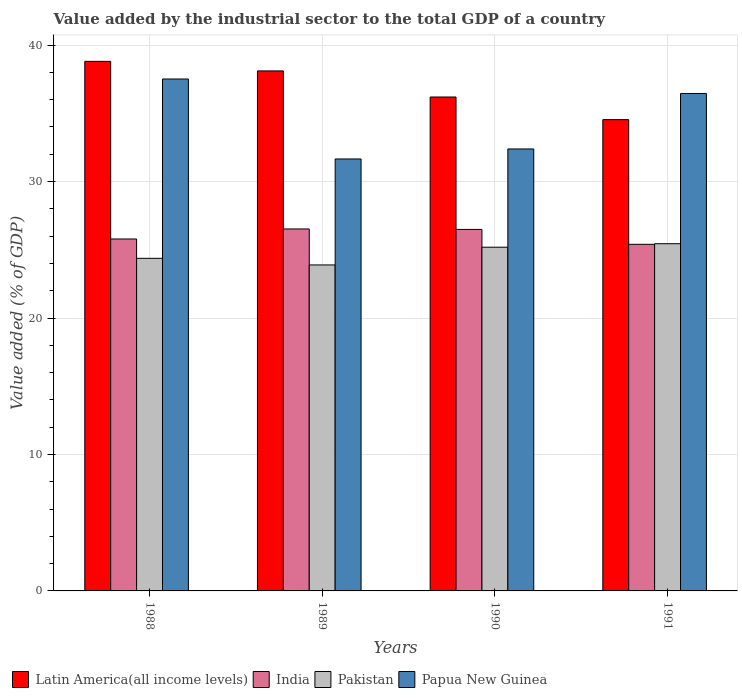How many different coloured bars are there?
Your response must be concise. 4. Are the number of bars per tick equal to the number of legend labels?
Your answer should be very brief. Yes. Are the number of bars on each tick of the X-axis equal?
Provide a short and direct response. Yes. How many bars are there on the 4th tick from the left?
Keep it short and to the point. 4. How many bars are there on the 3rd tick from the right?
Make the answer very short. 4. In how many cases, is the number of bars for a given year not equal to the number of legend labels?
Offer a very short reply. 0. What is the value added by the industrial sector to the total GDP in Papua New Guinea in 1991?
Ensure brevity in your answer.  36.46. Across all years, what is the maximum value added by the industrial sector to the total GDP in Pakistan?
Provide a succinct answer. 25.45. Across all years, what is the minimum value added by the industrial sector to the total GDP in Pakistan?
Provide a short and direct response. 23.89. What is the total value added by the industrial sector to the total GDP in Latin America(all income levels) in the graph?
Your answer should be compact. 147.66. What is the difference between the value added by the industrial sector to the total GDP in Pakistan in 1988 and that in 1991?
Offer a very short reply. -1.07. What is the difference between the value added by the industrial sector to the total GDP in Papua New Guinea in 1989 and the value added by the industrial sector to the total GDP in Latin America(all income levels) in 1991?
Your answer should be compact. -2.88. What is the average value added by the industrial sector to the total GDP in Papua New Guinea per year?
Ensure brevity in your answer.  34.51. In the year 1990, what is the difference between the value added by the industrial sector to the total GDP in Latin America(all income levels) and value added by the industrial sector to the total GDP in Pakistan?
Make the answer very short. 11.01. In how many years, is the value added by the industrial sector to the total GDP in Latin America(all income levels) greater than 16 %?
Offer a terse response. 4. What is the ratio of the value added by the industrial sector to the total GDP in Latin America(all income levels) in 1989 to that in 1991?
Provide a succinct answer. 1.1. Is the value added by the industrial sector to the total GDP in Pakistan in 1989 less than that in 1990?
Your answer should be very brief. Yes. What is the difference between the highest and the second highest value added by the industrial sector to the total GDP in Papua New Guinea?
Your answer should be compact. 1.06. What is the difference between the highest and the lowest value added by the industrial sector to the total GDP in Papua New Guinea?
Provide a short and direct response. 5.86. In how many years, is the value added by the industrial sector to the total GDP in Pakistan greater than the average value added by the industrial sector to the total GDP in Pakistan taken over all years?
Keep it short and to the point. 2. Is the sum of the value added by the industrial sector to the total GDP in Papua New Guinea in 1989 and 1990 greater than the maximum value added by the industrial sector to the total GDP in Pakistan across all years?
Provide a short and direct response. Yes. What does the 3rd bar from the left in 1990 represents?
Ensure brevity in your answer.  Pakistan. What does the 4th bar from the right in 1991 represents?
Make the answer very short. Latin America(all income levels). Is it the case that in every year, the sum of the value added by the industrial sector to the total GDP in India and value added by the industrial sector to the total GDP in Papua New Guinea is greater than the value added by the industrial sector to the total GDP in Latin America(all income levels)?
Make the answer very short. Yes. How many bars are there?
Provide a short and direct response. 16. What is the difference between two consecutive major ticks on the Y-axis?
Your answer should be compact. 10. Are the values on the major ticks of Y-axis written in scientific E-notation?
Offer a terse response. No. What is the title of the graph?
Keep it short and to the point. Value added by the industrial sector to the total GDP of a country. What is the label or title of the Y-axis?
Give a very brief answer. Value added (% of GDP). What is the Value added (% of GDP) in Latin America(all income levels) in 1988?
Give a very brief answer. 38.81. What is the Value added (% of GDP) in India in 1988?
Provide a succinct answer. 25.79. What is the Value added (% of GDP) of Pakistan in 1988?
Ensure brevity in your answer.  24.38. What is the Value added (% of GDP) in Papua New Guinea in 1988?
Your answer should be compact. 37.52. What is the Value added (% of GDP) in Latin America(all income levels) in 1989?
Ensure brevity in your answer.  38.11. What is the Value added (% of GDP) of India in 1989?
Your answer should be compact. 26.53. What is the Value added (% of GDP) in Pakistan in 1989?
Keep it short and to the point. 23.89. What is the Value added (% of GDP) in Papua New Guinea in 1989?
Your answer should be very brief. 31.66. What is the Value added (% of GDP) of Latin America(all income levels) in 1990?
Give a very brief answer. 36.2. What is the Value added (% of GDP) of India in 1990?
Your response must be concise. 26.49. What is the Value added (% of GDP) in Pakistan in 1990?
Your response must be concise. 25.19. What is the Value added (% of GDP) in Papua New Guinea in 1990?
Offer a very short reply. 32.39. What is the Value added (% of GDP) in Latin America(all income levels) in 1991?
Offer a very short reply. 34.54. What is the Value added (% of GDP) in India in 1991?
Provide a succinct answer. 25.4. What is the Value added (% of GDP) in Pakistan in 1991?
Your response must be concise. 25.45. What is the Value added (% of GDP) of Papua New Guinea in 1991?
Keep it short and to the point. 36.46. Across all years, what is the maximum Value added (% of GDP) of Latin America(all income levels)?
Provide a succinct answer. 38.81. Across all years, what is the maximum Value added (% of GDP) in India?
Your response must be concise. 26.53. Across all years, what is the maximum Value added (% of GDP) of Pakistan?
Give a very brief answer. 25.45. Across all years, what is the maximum Value added (% of GDP) in Papua New Guinea?
Offer a very short reply. 37.52. Across all years, what is the minimum Value added (% of GDP) of Latin America(all income levels)?
Your response must be concise. 34.54. Across all years, what is the minimum Value added (% of GDP) in India?
Offer a very short reply. 25.4. Across all years, what is the minimum Value added (% of GDP) of Pakistan?
Provide a short and direct response. 23.89. Across all years, what is the minimum Value added (% of GDP) of Papua New Guinea?
Give a very brief answer. 31.66. What is the total Value added (% of GDP) in Latin America(all income levels) in the graph?
Keep it short and to the point. 147.66. What is the total Value added (% of GDP) in India in the graph?
Keep it short and to the point. 104.21. What is the total Value added (% of GDP) of Pakistan in the graph?
Make the answer very short. 98.9. What is the total Value added (% of GDP) of Papua New Guinea in the graph?
Provide a succinct answer. 138.02. What is the difference between the Value added (% of GDP) of Latin America(all income levels) in 1988 and that in 1989?
Your answer should be compact. 0.7. What is the difference between the Value added (% of GDP) in India in 1988 and that in 1989?
Your response must be concise. -0.73. What is the difference between the Value added (% of GDP) in Pakistan in 1988 and that in 1989?
Make the answer very short. 0.49. What is the difference between the Value added (% of GDP) in Papua New Guinea in 1988 and that in 1989?
Keep it short and to the point. 5.86. What is the difference between the Value added (% of GDP) in Latin America(all income levels) in 1988 and that in 1990?
Ensure brevity in your answer.  2.61. What is the difference between the Value added (% of GDP) of India in 1988 and that in 1990?
Your answer should be very brief. -0.7. What is the difference between the Value added (% of GDP) of Pakistan in 1988 and that in 1990?
Give a very brief answer. -0.81. What is the difference between the Value added (% of GDP) of Papua New Guinea in 1988 and that in 1990?
Your response must be concise. 5.13. What is the difference between the Value added (% of GDP) of Latin America(all income levels) in 1988 and that in 1991?
Offer a terse response. 4.27. What is the difference between the Value added (% of GDP) in India in 1988 and that in 1991?
Offer a very short reply. 0.39. What is the difference between the Value added (% of GDP) in Pakistan in 1988 and that in 1991?
Give a very brief answer. -1.07. What is the difference between the Value added (% of GDP) of Papua New Guinea in 1988 and that in 1991?
Provide a succinct answer. 1.06. What is the difference between the Value added (% of GDP) in Latin America(all income levels) in 1989 and that in 1990?
Offer a terse response. 1.91. What is the difference between the Value added (% of GDP) in India in 1989 and that in 1990?
Provide a succinct answer. 0.03. What is the difference between the Value added (% of GDP) of Pakistan in 1989 and that in 1990?
Provide a succinct answer. -1.3. What is the difference between the Value added (% of GDP) in Papua New Guinea in 1989 and that in 1990?
Your response must be concise. -0.73. What is the difference between the Value added (% of GDP) in Latin America(all income levels) in 1989 and that in 1991?
Offer a terse response. 3.57. What is the difference between the Value added (% of GDP) in India in 1989 and that in 1991?
Your answer should be very brief. 1.13. What is the difference between the Value added (% of GDP) in Pakistan in 1989 and that in 1991?
Provide a succinct answer. -1.56. What is the difference between the Value added (% of GDP) of Papua New Guinea in 1989 and that in 1991?
Your answer should be very brief. -4.8. What is the difference between the Value added (% of GDP) of Latin America(all income levels) in 1990 and that in 1991?
Provide a succinct answer. 1.66. What is the difference between the Value added (% of GDP) in India in 1990 and that in 1991?
Ensure brevity in your answer.  1.09. What is the difference between the Value added (% of GDP) in Pakistan in 1990 and that in 1991?
Provide a succinct answer. -0.26. What is the difference between the Value added (% of GDP) of Papua New Guinea in 1990 and that in 1991?
Your answer should be very brief. -4.07. What is the difference between the Value added (% of GDP) of Latin America(all income levels) in 1988 and the Value added (% of GDP) of India in 1989?
Give a very brief answer. 12.28. What is the difference between the Value added (% of GDP) in Latin America(all income levels) in 1988 and the Value added (% of GDP) in Pakistan in 1989?
Your answer should be compact. 14.92. What is the difference between the Value added (% of GDP) in Latin America(all income levels) in 1988 and the Value added (% of GDP) in Papua New Guinea in 1989?
Give a very brief answer. 7.15. What is the difference between the Value added (% of GDP) in India in 1988 and the Value added (% of GDP) in Pakistan in 1989?
Give a very brief answer. 1.9. What is the difference between the Value added (% of GDP) in India in 1988 and the Value added (% of GDP) in Papua New Guinea in 1989?
Provide a succinct answer. -5.86. What is the difference between the Value added (% of GDP) in Pakistan in 1988 and the Value added (% of GDP) in Papua New Guinea in 1989?
Give a very brief answer. -7.28. What is the difference between the Value added (% of GDP) of Latin America(all income levels) in 1988 and the Value added (% of GDP) of India in 1990?
Offer a terse response. 12.32. What is the difference between the Value added (% of GDP) in Latin America(all income levels) in 1988 and the Value added (% of GDP) in Pakistan in 1990?
Make the answer very short. 13.62. What is the difference between the Value added (% of GDP) of Latin America(all income levels) in 1988 and the Value added (% of GDP) of Papua New Guinea in 1990?
Keep it short and to the point. 6.42. What is the difference between the Value added (% of GDP) in India in 1988 and the Value added (% of GDP) in Pakistan in 1990?
Offer a very short reply. 0.6. What is the difference between the Value added (% of GDP) in India in 1988 and the Value added (% of GDP) in Papua New Guinea in 1990?
Make the answer very short. -6.6. What is the difference between the Value added (% of GDP) of Pakistan in 1988 and the Value added (% of GDP) of Papua New Guinea in 1990?
Make the answer very short. -8.01. What is the difference between the Value added (% of GDP) of Latin America(all income levels) in 1988 and the Value added (% of GDP) of India in 1991?
Provide a succinct answer. 13.41. What is the difference between the Value added (% of GDP) of Latin America(all income levels) in 1988 and the Value added (% of GDP) of Pakistan in 1991?
Offer a very short reply. 13.36. What is the difference between the Value added (% of GDP) in Latin America(all income levels) in 1988 and the Value added (% of GDP) in Papua New Guinea in 1991?
Provide a succinct answer. 2.35. What is the difference between the Value added (% of GDP) of India in 1988 and the Value added (% of GDP) of Pakistan in 1991?
Ensure brevity in your answer.  0.35. What is the difference between the Value added (% of GDP) of India in 1988 and the Value added (% of GDP) of Papua New Guinea in 1991?
Your answer should be very brief. -10.66. What is the difference between the Value added (% of GDP) of Pakistan in 1988 and the Value added (% of GDP) of Papua New Guinea in 1991?
Your answer should be very brief. -12.08. What is the difference between the Value added (% of GDP) in Latin America(all income levels) in 1989 and the Value added (% of GDP) in India in 1990?
Your answer should be very brief. 11.62. What is the difference between the Value added (% of GDP) in Latin America(all income levels) in 1989 and the Value added (% of GDP) in Pakistan in 1990?
Ensure brevity in your answer.  12.92. What is the difference between the Value added (% of GDP) of Latin America(all income levels) in 1989 and the Value added (% of GDP) of Papua New Guinea in 1990?
Provide a short and direct response. 5.72. What is the difference between the Value added (% of GDP) of India in 1989 and the Value added (% of GDP) of Pakistan in 1990?
Make the answer very short. 1.34. What is the difference between the Value added (% of GDP) in India in 1989 and the Value added (% of GDP) in Papua New Guinea in 1990?
Provide a succinct answer. -5.86. What is the difference between the Value added (% of GDP) of Pakistan in 1989 and the Value added (% of GDP) of Papua New Guinea in 1990?
Make the answer very short. -8.5. What is the difference between the Value added (% of GDP) in Latin America(all income levels) in 1989 and the Value added (% of GDP) in India in 1991?
Your answer should be compact. 12.71. What is the difference between the Value added (% of GDP) in Latin America(all income levels) in 1989 and the Value added (% of GDP) in Pakistan in 1991?
Offer a very short reply. 12.66. What is the difference between the Value added (% of GDP) in Latin America(all income levels) in 1989 and the Value added (% of GDP) in Papua New Guinea in 1991?
Your answer should be compact. 1.65. What is the difference between the Value added (% of GDP) in India in 1989 and the Value added (% of GDP) in Pakistan in 1991?
Your answer should be very brief. 1.08. What is the difference between the Value added (% of GDP) of India in 1989 and the Value added (% of GDP) of Papua New Guinea in 1991?
Your answer should be very brief. -9.93. What is the difference between the Value added (% of GDP) in Pakistan in 1989 and the Value added (% of GDP) in Papua New Guinea in 1991?
Keep it short and to the point. -12.57. What is the difference between the Value added (% of GDP) of Latin America(all income levels) in 1990 and the Value added (% of GDP) of India in 1991?
Provide a succinct answer. 10.8. What is the difference between the Value added (% of GDP) in Latin America(all income levels) in 1990 and the Value added (% of GDP) in Pakistan in 1991?
Ensure brevity in your answer.  10.75. What is the difference between the Value added (% of GDP) in Latin America(all income levels) in 1990 and the Value added (% of GDP) in Papua New Guinea in 1991?
Keep it short and to the point. -0.26. What is the difference between the Value added (% of GDP) of India in 1990 and the Value added (% of GDP) of Pakistan in 1991?
Your response must be concise. 1.05. What is the difference between the Value added (% of GDP) in India in 1990 and the Value added (% of GDP) in Papua New Guinea in 1991?
Provide a short and direct response. -9.96. What is the difference between the Value added (% of GDP) in Pakistan in 1990 and the Value added (% of GDP) in Papua New Guinea in 1991?
Ensure brevity in your answer.  -11.27. What is the average Value added (% of GDP) of Latin America(all income levels) per year?
Provide a succinct answer. 36.91. What is the average Value added (% of GDP) of India per year?
Your answer should be very brief. 26.05. What is the average Value added (% of GDP) in Pakistan per year?
Give a very brief answer. 24.72. What is the average Value added (% of GDP) in Papua New Guinea per year?
Offer a terse response. 34.51. In the year 1988, what is the difference between the Value added (% of GDP) in Latin America(all income levels) and Value added (% of GDP) in India?
Keep it short and to the point. 13.02. In the year 1988, what is the difference between the Value added (% of GDP) of Latin America(all income levels) and Value added (% of GDP) of Pakistan?
Offer a terse response. 14.44. In the year 1988, what is the difference between the Value added (% of GDP) of Latin America(all income levels) and Value added (% of GDP) of Papua New Guinea?
Your response must be concise. 1.29. In the year 1988, what is the difference between the Value added (% of GDP) in India and Value added (% of GDP) in Pakistan?
Ensure brevity in your answer.  1.42. In the year 1988, what is the difference between the Value added (% of GDP) in India and Value added (% of GDP) in Papua New Guinea?
Give a very brief answer. -11.72. In the year 1988, what is the difference between the Value added (% of GDP) of Pakistan and Value added (% of GDP) of Papua New Guinea?
Give a very brief answer. -13.14. In the year 1989, what is the difference between the Value added (% of GDP) of Latin America(all income levels) and Value added (% of GDP) of India?
Your answer should be very brief. 11.58. In the year 1989, what is the difference between the Value added (% of GDP) of Latin America(all income levels) and Value added (% of GDP) of Pakistan?
Provide a short and direct response. 14.22. In the year 1989, what is the difference between the Value added (% of GDP) in Latin America(all income levels) and Value added (% of GDP) in Papua New Guinea?
Offer a very short reply. 6.45. In the year 1989, what is the difference between the Value added (% of GDP) in India and Value added (% of GDP) in Pakistan?
Your answer should be compact. 2.64. In the year 1989, what is the difference between the Value added (% of GDP) of India and Value added (% of GDP) of Papua New Guinea?
Your response must be concise. -5.13. In the year 1989, what is the difference between the Value added (% of GDP) in Pakistan and Value added (% of GDP) in Papua New Guinea?
Make the answer very short. -7.77. In the year 1990, what is the difference between the Value added (% of GDP) of Latin America(all income levels) and Value added (% of GDP) of India?
Your answer should be very brief. 9.7. In the year 1990, what is the difference between the Value added (% of GDP) of Latin America(all income levels) and Value added (% of GDP) of Pakistan?
Your answer should be very brief. 11.01. In the year 1990, what is the difference between the Value added (% of GDP) in Latin America(all income levels) and Value added (% of GDP) in Papua New Guinea?
Your response must be concise. 3.81. In the year 1990, what is the difference between the Value added (% of GDP) of India and Value added (% of GDP) of Pakistan?
Keep it short and to the point. 1.3. In the year 1990, what is the difference between the Value added (% of GDP) of India and Value added (% of GDP) of Papua New Guinea?
Give a very brief answer. -5.9. In the year 1990, what is the difference between the Value added (% of GDP) of Pakistan and Value added (% of GDP) of Papua New Guinea?
Make the answer very short. -7.2. In the year 1991, what is the difference between the Value added (% of GDP) in Latin America(all income levels) and Value added (% of GDP) in India?
Your answer should be very brief. 9.14. In the year 1991, what is the difference between the Value added (% of GDP) in Latin America(all income levels) and Value added (% of GDP) in Pakistan?
Your answer should be compact. 9.09. In the year 1991, what is the difference between the Value added (% of GDP) of Latin America(all income levels) and Value added (% of GDP) of Papua New Guinea?
Your answer should be compact. -1.92. In the year 1991, what is the difference between the Value added (% of GDP) in India and Value added (% of GDP) in Pakistan?
Ensure brevity in your answer.  -0.04. In the year 1991, what is the difference between the Value added (% of GDP) of India and Value added (% of GDP) of Papua New Guinea?
Your answer should be compact. -11.06. In the year 1991, what is the difference between the Value added (% of GDP) in Pakistan and Value added (% of GDP) in Papua New Guinea?
Provide a short and direct response. -11.01. What is the ratio of the Value added (% of GDP) in Latin America(all income levels) in 1988 to that in 1989?
Keep it short and to the point. 1.02. What is the ratio of the Value added (% of GDP) in India in 1988 to that in 1989?
Provide a succinct answer. 0.97. What is the ratio of the Value added (% of GDP) in Pakistan in 1988 to that in 1989?
Keep it short and to the point. 1.02. What is the ratio of the Value added (% of GDP) of Papua New Guinea in 1988 to that in 1989?
Your answer should be compact. 1.19. What is the ratio of the Value added (% of GDP) of Latin America(all income levels) in 1988 to that in 1990?
Provide a succinct answer. 1.07. What is the ratio of the Value added (% of GDP) in India in 1988 to that in 1990?
Make the answer very short. 0.97. What is the ratio of the Value added (% of GDP) in Pakistan in 1988 to that in 1990?
Provide a succinct answer. 0.97. What is the ratio of the Value added (% of GDP) of Papua New Guinea in 1988 to that in 1990?
Keep it short and to the point. 1.16. What is the ratio of the Value added (% of GDP) of Latin America(all income levels) in 1988 to that in 1991?
Provide a succinct answer. 1.12. What is the ratio of the Value added (% of GDP) of India in 1988 to that in 1991?
Make the answer very short. 1.02. What is the ratio of the Value added (% of GDP) in Pakistan in 1988 to that in 1991?
Ensure brevity in your answer.  0.96. What is the ratio of the Value added (% of GDP) in Papua New Guinea in 1988 to that in 1991?
Your answer should be very brief. 1.03. What is the ratio of the Value added (% of GDP) of Latin America(all income levels) in 1989 to that in 1990?
Your answer should be very brief. 1.05. What is the ratio of the Value added (% of GDP) of Pakistan in 1989 to that in 1990?
Your answer should be very brief. 0.95. What is the ratio of the Value added (% of GDP) in Papua New Guinea in 1989 to that in 1990?
Your answer should be very brief. 0.98. What is the ratio of the Value added (% of GDP) of Latin America(all income levels) in 1989 to that in 1991?
Give a very brief answer. 1.1. What is the ratio of the Value added (% of GDP) of India in 1989 to that in 1991?
Your answer should be very brief. 1.04. What is the ratio of the Value added (% of GDP) of Pakistan in 1989 to that in 1991?
Offer a very short reply. 0.94. What is the ratio of the Value added (% of GDP) of Papua New Guinea in 1989 to that in 1991?
Your response must be concise. 0.87. What is the ratio of the Value added (% of GDP) of Latin America(all income levels) in 1990 to that in 1991?
Your response must be concise. 1.05. What is the ratio of the Value added (% of GDP) of India in 1990 to that in 1991?
Offer a very short reply. 1.04. What is the ratio of the Value added (% of GDP) of Papua New Guinea in 1990 to that in 1991?
Offer a very short reply. 0.89. What is the difference between the highest and the second highest Value added (% of GDP) of Latin America(all income levels)?
Offer a terse response. 0.7. What is the difference between the highest and the second highest Value added (% of GDP) in India?
Give a very brief answer. 0.03. What is the difference between the highest and the second highest Value added (% of GDP) in Pakistan?
Offer a terse response. 0.26. What is the difference between the highest and the second highest Value added (% of GDP) of Papua New Guinea?
Make the answer very short. 1.06. What is the difference between the highest and the lowest Value added (% of GDP) of Latin America(all income levels)?
Provide a short and direct response. 4.27. What is the difference between the highest and the lowest Value added (% of GDP) of India?
Offer a terse response. 1.13. What is the difference between the highest and the lowest Value added (% of GDP) of Pakistan?
Offer a very short reply. 1.56. What is the difference between the highest and the lowest Value added (% of GDP) of Papua New Guinea?
Keep it short and to the point. 5.86. 